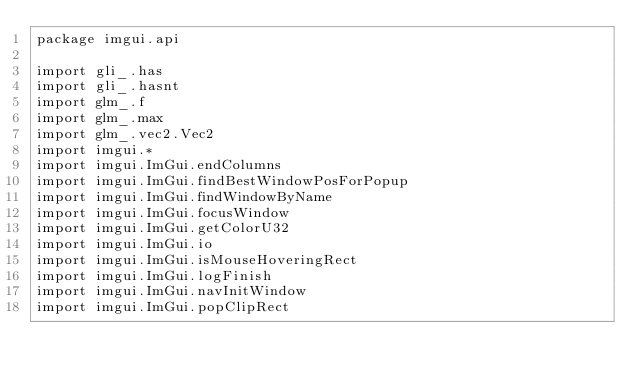Convert code to text. <code><loc_0><loc_0><loc_500><loc_500><_Kotlin_>package imgui.api

import gli_.has
import gli_.hasnt
import glm_.f
import glm_.max
import glm_.vec2.Vec2
import imgui.*
import imgui.ImGui.endColumns
import imgui.ImGui.findBestWindowPosForPopup
import imgui.ImGui.findWindowByName
import imgui.ImGui.focusWindow
import imgui.ImGui.getColorU32
import imgui.ImGui.io
import imgui.ImGui.isMouseHoveringRect
import imgui.ImGui.logFinish
import imgui.ImGui.navInitWindow
import imgui.ImGui.popClipRect</code> 